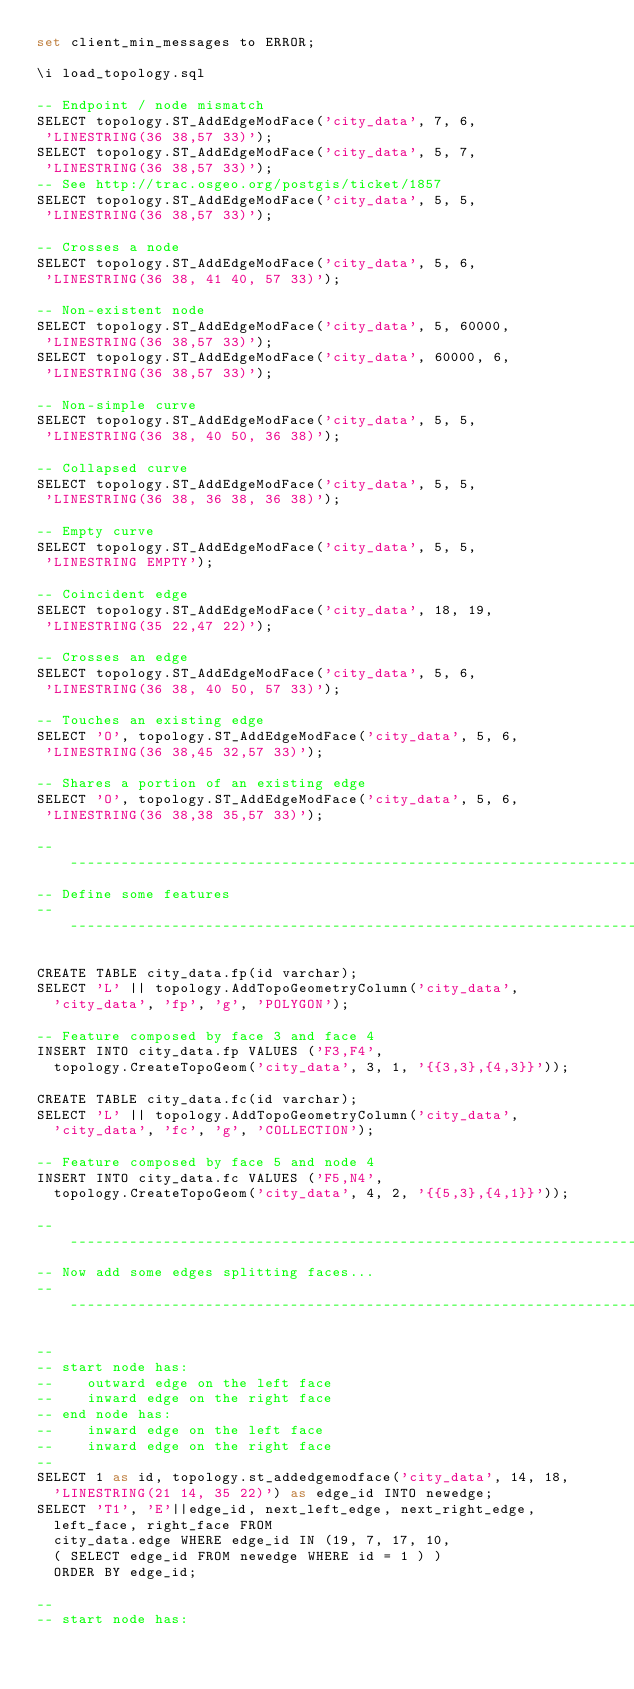Convert code to text. <code><loc_0><loc_0><loc_500><loc_500><_SQL_>set client_min_messages to ERROR;

\i load_topology.sql

-- Endpoint / node mismatch
SELECT topology.ST_AddEdgeModFace('city_data', 7, 6,
 'LINESTRING(36 38,57 33)');
SELECT topology.ST_AddEdgeModFace('city_data', 5, 7,
 'LINESTRING(36 38,57 33)');
-- See http://trac.osgeo.org/postgis/ticket/1857
SELECT topology.ST_AddEdgeModFace('city_data', 5, 5,
 'LINESTRING(36 38,57 33)');

-- Crosses a node
SELECT topology.ST_AddEdgeModFace('city_data', 5, 6,
 'LINESTRING(36 38, 41 40, 57 33)');

-- Non-existent node
SELECT topology.ST_AddEdgeModFace('city_data', 5, 60000,
 'LINESTRING(36 38,57 33)');
SELECT topology.ST_AddEdgeModFace('city_data', 60000, 6,
 'LINESTRING(36 38,57 33)');

-- Non-simple curve
SELECT topology.ST_AddEdgeModFace('city_data', 5, 5,
 'LINESTRING(36 38, 40 50, 36 38)');

-- Collapsed curve
SELECT topology.ST_AddEdgeModFace('city_data', 5, 5,
 'LINESTRING(36 38, 36 38, 36 38)');

-- Empty curve
SELECT topology.ST_AddEdgeModFace('city_data', 5, 5,
 'LINESTRING EMPTY');

-- Coincident edge
SELECT topology.ST_AddEdgeModFace('city_data', 18, 19,
 'LINESTRING(35 22,47 22)');

-- Crosses an edge
SELECT topology.ST_AddEdgeModFace('city_data', 5, 6,
 'LINESTRING(36 38, 40 50, 57 33)');

-- Touches an existing edge
SELECT 'O', topology.ST_AddEdgeModFace('city_data', 5, 6,
 'LINESTRING(36 38,45 32,57 33)');

-- Shares a portion of an existing edge
SELECT 'O', topology.ST_AddEdgeModFace('city_data', 5, 6,
 'LINESTRING(36 38,38 35,57 33)');

---------------------------------------------------------------------
-- Define some features
---------------------------------------------------------------------

CREATE TABLE city_data.fp(id varchar);
SELECT 'L' || topology.AddTopoGeometryColumn('city_data',
  'city_data', 'fp', 'g', 'POLYGON');

-- Feature composed by face 3 and face 4
INSERT INTO city_data.fp VALUES ('F3,F4',
  topology.CreateTopoGeom('city_data', 3, 1, '{{3,3},{4,3}}'));

CREATE TABLE city_data.fc(id varchar);
SELECT 'L' || topology.AddTopoGeometryColumn('city_data',
  'city_data', 'fc', 'g', 'COLLECTION');

-- Feature composed by face 5 and node 4
INSERT INTO city_data.fc VALUES ('F5,N4',
  topology.CreateTopoGeom('city_data', 4, 2, '{{5,3},{4,1}}'));

---------------------------------------------------------------------
-- Now add some edges splitting faces...
---------------------------------------------------------------------

--
-- start node has:
--    outward edge on the left face
--    inward edge on the right face
-- end node has:
--    inward edge on the left face
--    inward edge on the right face
--
SELECT 1 as id, topology.st_addedgemodface('city_data', 14, 18,
  'LINESTRING(21 14, 35 22)') as edge_id INTO newedge;
SELECT 'T1', 'E'||edge_id, next_left_edge, next_right_edge,
  left_face, right_face FROM
  city_data.edge WHERE edge_id IN (19, 7, 17, 10,
  ( SELECT edge_id FROM newedge WHERE id = 1 ) )
  ORDER BY edge_id;

--
-- start node has:</code> 